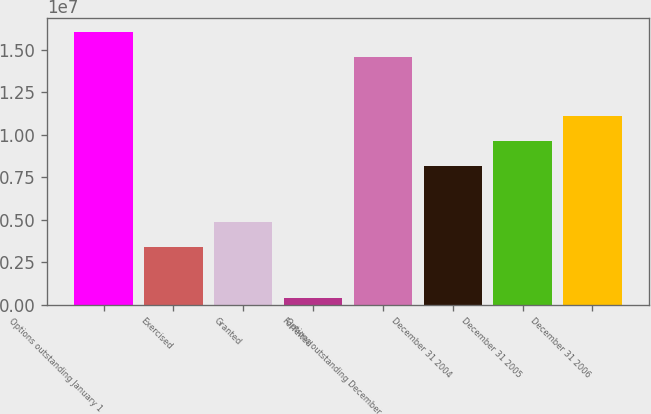Convert chart to OTSL. <chart><loc_0><loc_0><loc_500><loc_500><bar_chart><fcel>Options outstanding January 1<fcel>Exercised<fcel>Granted<fcel>Forfeited<fcel>Options outstanding December<fcel>December 31 2004<fcel>December 31 2005<fcel>December 31 2006<nl><fcel>1.60373e+07<fcel>3.37975e+06<fcel>4.86573e+06<fcel>379790<fcel>1.45513e+07<fcel>8.13576e+06<fcel>9.62174e+06<fcel>1.11077e+07<nl></chart> 